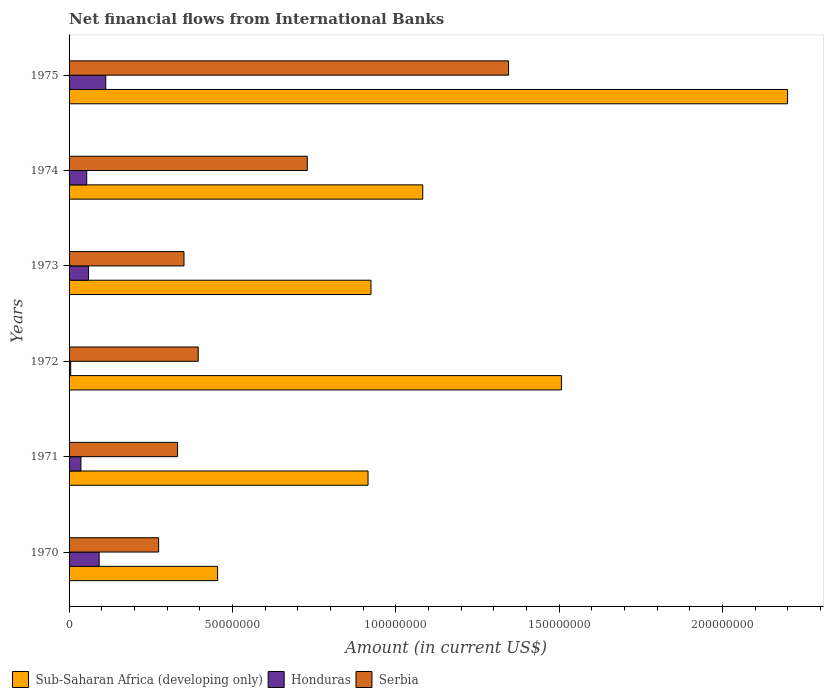Are the number of bars per tick equal to the number of legend labels?
Offer a very short reply. Yes. How many bars are there on the 1st tick from the top?
Provide a succinct answer. 3. In how many cases, is the number of bars for a given year not equal to the number of legend labels?
Provide a succinct answer. 0. What is the net financial aid flows in Honduras in 1970?
Offer a terse response. 9.21e+06. Across all years, what is the maximum net financial aid flows in Honduras?
Your response must be concise. 1.12e+07. Across all years, what is the minimum net financial aid flows in Sub-Saharan Africa (developing only)?
Offer a very short reply. 4.55e+07. In which year was the net financial aid flows in Honduras maximum?
Make the answer very short. 1975. What is the total net financial aid flows in Sub-Saharan Africa (developing only) in the graph?
Your answer should be compact. 7.08e+08. What is the difference between the net financial aid flows in Serbia in 1971 and that in 1972?
Ensure brevity in your answer.  -6.34e+06. What is the difference between the net financial aid flows in Sub-Saharan Africa (developing only) in 1974 and the net financial aid flows in Serbia in 1972?
Offer a very short reply. 6.87e+07. What is the average net financial aid flows in Honduras per year?
Make the answer very short. 5.99e+06. In the year 1971, what is the difference between the net financial aid flows in Honduras and net financial aid flows in Serbia?
Your answer should be compact. -2.96e+07. What is the ratio of the net financial aid flows in Sub-Saharan Africa (developing only) in 1972 to that in 1974?
Your answer should be compact. 1.39. Is the net financial aid flows in Sub-Saharan Africa (developing only) in 1974 less than that in 1975?
Provide a short and direct response. Yes. What is the difference between the highest and the second highest net financial aid flows in Serbia?
Give a very brief answer. 6.16e+07. What is the difference between the highest and the lowest net financial aid flows in Sub-Saharan Africa (developing only)?
Your answer should be compact. 1.74e+08. What does the 1st bar from the top in 1975 represents?
Your answer should be compact. Serbia. What does the 1st bar from the bottom in 1975 represents?
Ensure brevity in your answer.  Sub-Saharan Africa (developing only). Is it the case that in every year, the sum of the net financial aid flows in Sub-Saharan Africa (developing only) and net financial aid flows in Honduras is greater than the net financial aid flows in Serbia?
Your answer should be very brief. Yes. What is the difference between two consecutive major ticks on the X-axis?
Provide a short and direct response. 5.00e+07. Are the values on the major ticks of X-axis written in scientific E-notation?
Make the answer very short. No. Does the graph contain grids?
Provide a short and direct response. No. How many legend labels are there?
Make the answer very short. 3. How are the legend labels stacked?
Your answer should be very brief. Horizontal. What is the title of the graph?
Offer a very short reply. Net financial flows from International Banks. What is the label or title of the X-axis?
Offer a terse response. Amount (in current US$). What is the label or title of the Y-axis?
Your answer should be compact. Years. What is the Amount (in current US$) of Sub-Saharan Africa (developing only) in 1970?
Your response must be concise. 4.55e+07. What is the Amount (in current US$) of Honduras in 1970?
Offer a very short reply. 9.21e+06. What is the Amount (in current US$) of Serbia in 1970?
Offer a terse response. 2.74e+07. What is the Amount (in current US$) in Sub-Saharan Africa (developing only) in 1971?
Your answer should be compact. 9.15e+07. What is the Amount (in current US$) of Honduras in 1971?
Give a very brief answer. 3.63e+06. What is the Amount (in current US$) in Serbia in 1971?
Your answer should be very brief. 3.32e+07. What is the Amount (in current US$) of Sub-Saharan Africa (developing only) in 1972?
Your answer should be very brief. 1.51e+08. What is the Amount (in current US$) of Honduras in 1972?
Provide a succinct answer. 5.02e+05. What is the Amount (in current US$) of Serbia in 1972?
Make the answer very short. 3.95e+07. What is the Amount (in current US$) in Sub-Saharan Africa (developing only) in 1973?
Provide a succinct answer. 9.24e+07. What is the Amount (in current US$) of Honduras in 1973?
Provide a short and direct response. 5.94e+06. What is the Amount (in current US$) in Serbia in 1973?
Ensure brevity in your answer.  3.52e+07. What is the Amount (in current US$) of Sub-Saharan Africa (developing only) in 1974?
Offer a very short reply. 1.08e+08. What is the Amount (in current US$) in Honduras in 1974?
Your answer should be compact. 5.40e+06. What is the Amount (in current US$) of Serbia in 1974?
Give a very brief answer. 7.29e+07. What is the Amount (in current US$) of Sub-Saharan Africa (developing only) in 1975?
Your answer should be compact. 2.20e+08. What is the Amount (in current US$) of Honduras in 1975?
Ensure brevity in your answer.  1.12e+07. What is the Amount (in current US$) of Serbia in 1975?
Offer a terse response. 1.35e+08. Across all years, what is the maximum Amount (in current US$) in Sub-Saharan Africa (developing only)?
Your answer should be compact. 2.20e+08. Across all years, what is the maximum Amount (in current US$) of Honduras?
Provide a succinct answer. 1.12e+07. Across all years, what is the maximum Amount (in current US$) of Serbia?
Your answer should be compact. 1.35e+08. Across all years, what is the minimum Amount (in current US$) in Sub-Saharan Africa (developing only)?
Keep it short and to the point. 4.55e+07. Across all years, what is the minimum Amount (in current US$) of Honduras?
Your response must be concise. 5.02e+05. Across all years, what is the minimum Amount (in current US$) in Serbia?
Make the answer very short. 2.74e+07. What is the total Amount (in current US$) of Sub-Saharan Africa (developing only) in the graph?
Make the answer very short. 7.08e+08. What is the total Amount (in current US$) of Honduras in the graph?
Offer a terse response. 3.59e+07. What is the total Amount (in current US$) in Serbia in the graph?
Make the answer very short. 3.43e+08. What is the difference between the Amount (in current US$) in Sub-Saharan Africa (developing only) in 1970 and that in 1971?
Provide a succinct answer. -4.61e+07. What is the difference between the Amount (in current US$) in Honduras in 1970 and that in 1971?
Your answer should be compact. 5.58e+06. What is the difference between the Amount (in current US$) in Serbia in 1970 and that in 1971?
Your response must be concise. -5.78e+06. What is the difference between the Amount (in current US$) of Sub-Saharan Africa (developing only) in 1970 and that in 1972?
Keep it short and to the point. -1.05e+08. What is the difference between the Amount (in current US$) in Honduras in 1970 and that in 1972?
Your answer should be compact. 8.71e+06. What is the difference between the Amount (in current US$) in Serbia in 1970 and that in 1972?
Make the answer very short. -1.21e+07. What is the difference between the Amount (in current US$) of Sub-Saharan Africa (developing only) in 1970 and that in 1973?
Your answer should be compact. -4.70e+07. What is the difference between the Amount (in current US$) in Honduras in 1970 and that in 1973?
Your answer should be very brief. 3.27e+06. What is the difference between the Amount (in current US$) in Serbia in 1970 and that in 1973?
Ensure brevity in your answer.  -7.76e+06. What is the difference between the Amount (in current US$) of Sub-Saharan Africa (developing only) in 1970 and that in 1974?
Your answer should be compact. -6.28e+07. What is the difference between the Amount (in current US$) of Honduras in 1970 and that in 1974?
Your answer should be compact. 3.81e+06. What is the difference between the Amount (in current US$) in Serbia in 1970 and that in 1974?
Your answer should be compact. -4.55e+07. What is the difference between the Amount (in current US$) in Sub-Saharan Africa (developing only) in 1970 and that in 1975?
Give a very brief answer. -1.74e+08. What is the difference between the Amount (in current US$) in Honduras in 1970 and that in 1975?
Ensure brevity in your answer.  -2.03e+06. What is the difference between the Amount (in current US$) of Serbia in 1970 and that in 1975?
Provide a succinct answer. -1.07e+08. What is the difference between the Amount (in current US$) in Sub-Saharan Africa (developing only) in 1971 and that in 1972?
Provide a succinct answer. -5.92e+07. What is the difference between the Amount (in current US$) of Honduras in 1971 and that in 1972?
Make the answer very short. 3.13e+06. What is the difference between the Amount (in current US$) of Serbia in 1971 and that in 1972?
Offer a terse response. -6.34e+06. What is the difference between the Amount (in current US$) of Sub-Saharan Africa (developing only) in 1971 and that in 1973?
Your answer should be very brief. -9.02e+05. What is the difference between the Amount (in current US$) in Honduras in 1971 and that in 1973?
Keep it short and to the point. -2.30e+06. What is the difference between the Amount (in current US$) of Serbia in 1971 and that in 1973?
Provide a short and direct response. -1.98e+06. What is the difference between the Amount (in current US$) of Sub-Saharan Africa (developing only) in 1971 and that in 1974?
Offer a very short reply. -1.68e+07. What is the difference between the Amount (in current US$) in Honduras in 1971 and that in 1974?
Your answer should be compact. -1.77e+06. What is the difference between the Amount (in current US$) of Serbia in 1971 and that in 1974?
Offer a very short reply. -3.97e+07. What is the difference between the Amount (in current US$) of Sub-Saharan Africa (developing only) in 1971 and that in 1975?
Give a very brief answer. -1.28e+08. What is the difference between the Amount (in current US$) of Honduras in 1971 and that in 1975?
Your answer should be compact. -7.60e+06. What is the difference between the Amount (in current US$) in Serbia in 1971 and that in 1975?
Give a very brief answer. -1.01e+08. What is the difference between the Amount (in current US$) of Sub-Saharan Africa (developing only) in 1972 and that in 1973?
Your response must be concise. 5.83e+07. What is the difference between the Amount (in current US$) of Honduras in 1972 and that in 1973?
Offer a very short reply. -5.43e+06. What is the difference between the Amount (in current US$) in Serbia in 1972 and that in 1973?
Your answer should be very brief. 4.36e+06. What is the difference between the Amount (in current US$) of Sub-Saharan Africa (developing only) in 1972 and that in 1974?
Keep it short and to the point. 4.24e+07. What is the difference between the Amount (in current US$) of Honduras in 1972 and that in 1974?
Offer a very short reply. -4.90e+06. What is the difference between the Amount (in current US$) in Serbia in 1972 and that in 1974?
Provide a succinct answer. -3.34e+07. What is the difference between the Amount (in current US$) of Sub-Saharan Africa (developing only) in 1972 and that in 1975?
Keep it short and to the point. -6.92e+07. What is the difference between the Amount (in current US$) in Honduras in 1972 and that in 1975?
Keep it short and to the point. -1.07e+07. What is the difference between the Amount (in current US$) in Serbia in 1972 and that in 1975?
Your answer should be very brief. -9.50e+07. What is the difference between the Amount (in current US$) in Sub-Saharan Africa (developing only) in 1973 and that in 1974?
Your answer should be very brief. -1.58e+07. What is the difference between the Amount (in current US$) in Honduras in 1973 and that in 1974?
Your answer should be very brief. 5.33e+05. What is the difference between the Amount (in current US$) of Serbia in 1973 and that in 1974?
Offer a very short reply. -3.77e+07. What is the difference between the Amount (in current US$) in Sub-Saharan Africa (developing only) in 1973 and that in 1975?
Keep it short and to the point. -1.28e+08. What is the difference between the Amount (in current US$) in Honduras in 1973 and that in 1975?
Provide a short and direct response. -5.30e+06. What is the difference between the Amount (in current US$) in Serbia in 1973 and that in 1975?
Make the answer very short. -9.94e+07. What is the difference between the Amount (in current US$) of Sub-Saharan Africa (developing only) in 1974 and that in 1975?
Your response must be concise. -1.12e+08. What is the difference between the Amount (in current US$) of Honduras in 1974 and that in 1975?
Offer a very short reply. -5.83e+06. What is the difference between the Amount (in current US$) of Serbia in 1974 and that in 1975?
Your answer should be very brief. -6.16e+07. What is the difference between the Amount (in current US$) in Sub-Saharan Africa (developing only) in 1970 and the Amount (in current US$) in Honduras in 1971?
Keep it short and to the point. 4.18e+07. What is the difference between the Amount (in current US$) of Sub-Saharan Africa (developing only) in 1970 and the Amount (in current US$) of Serbia in 1971?
Keep it short and to the point. 1.23e+07. What is the difference between the Amount (in current US$) in Honduras in 1970 and the Amount (in current US$) in Serbia in 1971?
Provide a short and direct response. -2.40e+07. What is the difference between the Amount (in current US$) of Sub-Saharan Africa (developing only) in 1970 and the Amount (in current US$) of Honduras in 1972?
Your answer should be compact. 4.50e+07. What is the difference between the Amount (in current US$) in Sub-Saharan Africa (developing only) in 1970 and the Amount (in current US$) in Serbia in 1972?
Your answer should be compact. 5.93e+06. What is the difference between the Amount (in current US$) in Honduras in 1970 and the Amount (in current US$) in Serbia in 1972?
Provide a short and direct response. -3.03e+07. What is the difference between the Amount (in current US$) in Sub-Saharan Africa (developing only) in 1970 and the Amount (in current US$) in Honduras in 1973?
Provide a short and direct response. 3.95e+07. What is the difference between the Amount (in current US$) of Sub-Saharan Africa (developing only) in 1970 and the Amount (in current US$) of Serbia in 1973?
Your answer should be compact. 1.03e+07. What is the difference between the Amount (in current US$) in Honduras in 1970 and the Amount (in current US$) in Serbia in 1973?
Offer a terse response. -2.60e+07. What is the difference between the Amount (in current US$) of Sub-Saharan Africa (developing only) in 1970 and the Amount (in current US$) of Honduras in 1974?
Keep it short and to the point. 4.01e+07. What is the difference between the Amount (in current US$) of Sub-Saharan Africa (developing only) in 1970 and the Amount (in current US$) of Serbia in 1974?
Keep it short and to the point. -2.75e+07. What is the difference between the Amount (in current US$) in Honduras in 1970 and the Amount (in current US$) in Serbia in 1974?
Offer a very short reply. -6.37e+07. What is the difference between the Amount (in current US$) of Sub-Saharan Africa (developing only) in 1970 and the Amount (in current US$) of Honduras in 1975?
Your answer should be compact. 3.42e+07. What is the difference between the Amount (in current US$) of Sub-Saharan Africa (developing only) in 1970 and the Amount (in current US$) of Serbia in 1975?
Your answer should be very brief. -8.91e+07. What is the difference between the Amount (in current US$) of Honduras in 1970 and the Amount (in current US$) of Serbia in 1975?
Offer a terse response. -1.25e+08. What is the difference between the Amount (in current US$) in Sub-Saharan Africa (developing only) in 1971 and the Amount (in current US$) in Honduras in 1972?
Provide a short and direct response. 9.10e+07. What is the difference between the Amount (in current US$) of Sub-Saharan Africa (developing only) in 1971 and the Amount (in current US$) of Serbia in 1972?
Provide a short and direct response. 5.20e+07. What is the difference between the Amount (in current US$) of Honduras in 1971 and the Amount (in current US$) of Serbia in 1972?
Keep it short and to the point. -3.59e+07. What is the difference between the Amount (in current US$) of Sub-Saharan Africa (developing only) in 1971 and the Amount (in current US$) of Honduras in 1973?
Your answer should be compact. 8.56e+07. What is the difference between the Amount (in current US$) of Sub-Saharan Africa (developing only) in 1971 and the Amount (in current US$) of Serbia in 1973?
Your response must be concise. 5.63e+07. What is the difference between the Amount (in current US$) in Honduras in 1971 and the Amount (in current US$) in Serbia in 1973?
Ensure brevity in your answer.  -3.15e+07. What is the difference between the Amount (in current US$) of Sub-Saharan Africa (developing only) in 1971 and the Amount (in current US$) of Honduras in 1974?
Your response must be concise. 8.61e+07. What is the difference between the Amount (in current US$) of Sub-Saharan Africa (developing only) in 1971 and the Amount (in current US$) of Serbia in 1974?
Offer a very short reply. 1.86e+07. What is the difference between the Amount (in current US$) of Honduras in 1971 and the Amount (in current US$) of Serbia in 1974?
Provide a short and direct response. -6.93e+07. What is the difference between the Amount (in current US$) in Sub-Saharan Africa (developing only) in 1971 and the Amount (in current US$) in Honduras in 1975?
Provide a succinct answer. 8.03e+07. What is the difference between the Amount (in current US$) in Sub-Saharan Africa (developing only) in 1971 and the Amount (in current US$) in Serbia in 1975?
Your answer should be very brief. -4.30e+07. What is the difference between the Amount (in current US$) of Honduras in 1971 and the Amount (in current US$) of Serbia in 1975?
Give a very brief answer. -1.31e+08. What is the difference between the Amount (in current US$) of Sub-Saharan Africa (developing only) in 1972 and the Amount (in current US$) of Honduras in 1973?
Make the answer very short. 1.45e+08. What is the difference between the Amount (in current US$) of Sub-Saharan Africa (developing only) in 1972 and the Amount (in current US$) of Serbia in 1973?
Your answer should be very brief. 1.16e+08. What is the difference between the Amount (in current US$) in Honduras in 1972 and the Amount (in current US$) in Serbia in 1973?
Keep it short and to the point. -3.47e+07. What is the difference between the Amount (in current US$) in Sub-Saharan Africa (developing only) in 1972 and the Amount (in current US$) in Honduras in 1974?
Your response must be concise. 1.45e+08. What is the difference between the Amount (in current US$) in Sub-Saharan Africa (developing only) in 1972 and the Amount (in current US$) in Serbia in 1974?
Provide a succinct answer. 7.78e+07. What is the difference between the Amount (in current US$) in Honduras in 1972 and the Amount (in current US$) in Serbia in 1974?
Offer a very short reply. -7.24e+07. What is the difference between the Amount (in current US$) of Sub-Saharan Africa (developing only) in 1972 and the Amount (in current US$) of Honduras in 1975?
Offer a very short reply. 1.39e+08. What is the difference between the Amount (in current US$) in Sub-Saharan Africa (developing only) in 1972 and the Amount (in current US$) in Serbia in 1975?
Your answer should be very brief. 1.62e+07. What is the difference between the Amount (in current US$) of Honduras in 1972 and the Amount (in current US$) of Serbia in 1975?
Make the answer very short. -1.34e+08. What is the difference between the Amount (in current US$) in Sub-Saharan Africa (developing only) in 1973 and the Amount (in current US$) in Honduras in 1974?
Keep it short and to the point. 8.70e+07. What is the difference between the Amount (in current US$) in Sub-Saharan Africa (developing only) in 1973 and the Amount (in current US$) in Serbia in 1974?
Make the answer very short. 1.95e+07. What is the difference between the Amount (in current US$) in Honduras in 1973 and the Amount (in current US$) in Serbia in 1974?
Give a very brief answer. -6.70e+07. What is the difference between the Amount (in current US$) of Sub-Saharan Africa (developing only) in 1973 and the Amount (in current US$) of Honduras in 1975?
Your response must be concise. 8.12e+07. What is the difference between the Amount (in current US$) of Sub-Saharan Africa (developing only) in 1973 and the Amount (in current US$) of Serbia in 1975?
Your response must be concise. -4.21e+07. What is the difference between the Amount (in current US$) of Honduras in 1973 and the Amount (in current US$) of Serbia in 1975?
Your answer should be very brief. -1.29e+08. What is the difference between the Amount (in current US$) of Sub-Saharan Africa (developing only) in 1974 and the Amount (in current US$) of Honduras in 1975?
Your answer should be compact. 9.70e+07. What is the difference between the Amount (in current US$) of Sub-Saharan Africa (developing only) in 1974 and the Amount (in current US$) of Serbia in 1975?
Ensure brevity in your answer.  -2.63e+07. What is the difference between the Amount (in current US$) of Honduras in 1974 and the Amount (in current US$) of Serbia in 1975?
Give a very brief answer. -1.29e+08. What is the average Amount (in current US$) in Sub-Saharan Africa (developing only) per year?
Your response must be concise. 1.18e+08. What is the average Amount (in current US$) of Honduras per year?
Make the answer very short. 5.99e+06. What is the average Amount (in current US$) of Serbia per year?
Your answer should be compact. 5.71e+07. In the year 1970, what is the difference between the Amount (in current US$) of Sub-Saharan Africa (developing only) and Amount (in current US$) of Honduras?
Offer a terse response. 3.63e+07. In the year 1970, what is the difference between the Amount (in current US$) of Sub-Saharan Africa (developing only) and Amount (in current US$) of Serbia?
Keep it short and to the point. 1.80e+07. In the year 1970, what is the difference between the Amount (in current US$) in Honduras and Amount (in current US$) in Serbia?
Your response must be concise. -1.82e+07. In the year 1971, what is the difference between the Amount (in current US$) in Sub-Saharan Africa (developing only) and Amount (in current US$) in Honduras?
Offer a terse response. 8.79e+07. In the year 1971, what is the difference between the Amount (in current US$) of Sub-Saharan Africa (developing only) and Amount (in current US$) of Serbia?
Make the answer very short. 5.83e+07. In the year 1971, what is the difference between the Amount (in current US$) of Honduras and Amount (in current US$) of Serbia?
Provide a succinct answer. -2.96e+07. In the year 1972, what is the difference between the Amount (in current US$) in Sub-Saharan Africa (developing only) and Amount (in current US$) in Honduras?
Provide a short and direct response. 1.50e+08. In the year 1972, what is the difference between the Amount (in current US$) of Sub-Saharan Africa (developing only) and Amount (in current US$) of Serbia?
Provide a succinct answer. 1.11e+08. In the year 1972, what is the difference between the Amount (in current US$) in Honduras and Amount (in current US$) in Serbia?
Give a very brief answer. -3.90e+07. In the year 1973, what is the difference between the Amount (in current US$) of Sub-Saharan Africa (developing only) and Amount (in current US$) of Honduras?
Your answer should be compact. 8.65e+07. In the year 1973, what is the difference between the Amount (in current US$) of Sub-Saharan Africa (developing only) and Amount (in current US$) of Serbia?
Keep it short and to the point. 5.72e+07. In the year 1973, what is the difference between the Amount (in current US$) of Honduras and Amount (in current US$) of Serbia?
Ensure brevity in your answer.  -2.92e+07. In the year 1974, what is the difference between the Amount (in current US$) in Sub-Saharan Africa (developing only) and Amount (in current US$) in Honduras?
Ensure brevity in your answer.  1.03e+08. In the year 1974, what is the difference between the Amount (in current US$) in Sub-Saharan Africa (developing only) and Amount (in current US$) in Serbia?
Your answer should be very brief. 3.53e+07. In the year 1974, what is the difference between the Amount (in current US$) of Honduras and Amount (in current US$) of Serbia?
Make the answer very short. -6.75e+07. In the year 1975, what is the difference between the Amount (in current US$) of Sub-Saharan Africa (developing only) and Amount (in current US$) of Honduras?
Ensure brevity in your answer.  2.09e+08. In the year 1975, what is the difference between the Amount (in current US$) of Sub-Saharan Africa (developing only) and Amount (in current US$) of Serbia?
Ensure brevity in your answer.  8.54e+07. In the year 1975, what is the difference between the Amount (in current US$) of Honduras and Amount (in current US$) of Serbia?
Make the answer very short. -1.23e+08. What is the ratio of the Amount (in current US$) in Sub-Saharan Africa (developing only) in 1970 to that in 1971?
Keep it short and to the point. 0.5. What is the ratio of the Amount (in current US$) in Honduras in 1970 to that in 1971?
Provide a succinct answer. 2.54. What is the ratio of the Amount (in current US$) of Serbia in 1970 to that in 1971?
Keep it short and to the point. 0.83. What is the ratio of the Amount (in current US$) in Sub-Saharan Africa (developing only) in 1970 to that in 1972?
Provide a short and direct response. 0.3. What is the ratio of the Amount (in current US$) of Honduras in 1970 to that in 1972?
Ensure brevity in your answer.  18.34. What is the ratio of the Amount (in current US$) in Serbia in 1970 to that in 1972?
Offer a terse response. 0.69. What is the ratio of the Amount (in current US$) of Sub-Saharan Africa (developing only) in 1970 to that in 1973?
Your answer should be compact. 0.49. What is the ratio of the Amount (in current US$) in Honduras in 1970 to that in 1973?
Your response must be concise. 1.55. What is the ratio of the Amount (in current US$) in Serbia in 1970 to that in 1973?
Keep it short and to the point. 0.78. What is the ratio of the Amount (in current US$) in Sub-Saharan Africa (developing only) in 1970 to that in 1974?
Your answer should be very brief. 0.42. What is the ratio of the Amount (in current US$) in Honduras in 1970 to that in 1974?
Give a very brief answer. 1.7. What is the ratio of the Amount (in current US$) of Serbia in 1970 to that in 1974?
Provide a succinct answer. 0.38. What is the ratio of the Amount (in current US$) in Sub-Saharan Africa (developing only) in 1970 to that in 1975?
Provide a short and direct response. 0.21. What is the ratio of the Amount (in current US$) of Honduras in 1970 to that in 1975?
Ensure brevity in your answer.  0.82. What is the ratio of the Amount (in current US$) in Serbia in 1970 to that in 1975?
Provide a succinct answer. 0.2. What is the ratio of the Amount (in current US$) in Sub-Saharan Africa (developing only) in 1971 to that in 1972?
Offer a very short reply. 0.61. What is the ratio of the Amount (in current US$) of Honduras in 1971 to that in 1972?
Provide a short and direct response. 7.24. What is the ratio of the Amount (in current US$) of Serbia in 1971 to that in 1972?
Ensure brevity in your answer.  0.84. What is the ratio of the Amount (in current US$) of Sub-Saharan Africa (developing only) in 1971 to that in 1973?
Give a very brief answer. 0.99. What is the ratio of the Amount (in current US$) in Honduras in 1971 to that in 1973?
Your answer should be very brief. 0.61. What is the ratio of the Amount (in current US$) in Serbia in 1971 to that in 1973?
Give a very brief answer. 0.94. What is the ratio of the Amount (in current US$) in Sub-Saharan Africa (developing only) in 1971 to that in 1974?
Make the answer very short. 0.85. What is the ratio of the Amount (in current US$) of Honduras in 1971 to that in 1974?
Ensure brevity in your answer.  0.67. What is the ratio of the Amount (in current US$) of Serbia in 1971 to that in 1974?
Your response must be concise. 0.46. What is the ratio of the Amount (in current US$) of Sub-Saharan Africa (developing only) in 1971 to that in 1975?
Provide a short and direct response. 0.42. What is the ratio of the Amount (in current US$) of Honduras in 1971 to that in 1975?
Offer a terse response. 0.32. What is the ratio of the Amount (in current US$) of Serbia in 1971 to that in 1975?
Your answer should be compact. 0.25. What is the ratio of the Amount (in current US$) in Sub-Saharan Africa (developing only) in 1972 to that in 1973?
Offer a terse response. 1.63. What is the ratio of the Amount (in current US$) of Honduras in 1972 to that in 1973?
Ensure brevity in your answer.  0.08. What is the ratio of the Amount (in current US$) of Serbia in 1972 to that in 1973?
Your answer should be very brief. 1.12. What is the ratio of the Amount (in current US$) in Sub-Saharan Africa (developing only) in 1972 to that in 1974?
Offer a very short reply. 1.39. What is the ratio of the Amount (in current US$) in Honduras in 1972 to that in 1974?
Offer a very short reply. 0.09. What is the ratio of the Amount (in current US$) in Serbia in 1972 to that in 1974?
Your response must be concise. 0.54. What is the ratio of the Amount (in current US$) in Sub-Saharan Africa (developing only) in 1972 to that in 1975?
Give a very brief answer. 0.69. What is the ratio of the Amount (in current US$) of Honduras in 1972 to that in 1975?
Offer a very short reply. 0.04. What is the ratio of the Amount (in current US$) in Serbia in 1972 to that in 1975?
Provide a short and direct response. 0.29. What is the ratio of the Amount (in current US$) of Sub-Saharan Africa (developing only) in 1973 to that in 1974?
Your response must be concise. 0.85. What is the ratio of the Amount (in current US$) of Honduras in 1973 to that in 1974?
Make the answer very short. 1.1. What is the ratio of the Amount (in current US$) of Serbia in 1973 to that in 1974?
Keep it short and to the point. 0.48. What is the ratio of the Amount (in current US$) in Sub-Saharan Africa (developing only) in 1973 to that in 1975?
Keep it short and to the point. 0.42. What is the ratio of the Amount (in current US$) of Honduras in 1973 to that in 1975?
Provide a succinct answer. 0.53. What is the ratio of the Amount (in current US$) in Serbia in 1973 to that in 1975?
Your answer should be very brief. 0.26. What is the ratio of the Amount (in current US$) in Sub-Saharan Africa (developing only) in 1974 to that in 1975?
Keep it short and to the point. 0.49. What is the ratio of the Amount (in current US$) in Honduras in 1974 to that in 1975?
Offer a terse response. 0.48. What is the ratio of the Amount (in current US$) in Serbia in 1974 to that in 1975?
Provide a short and direct response. 0.54. What is the difference between the highest and the second highest Amount (in current US$) in Sub-Saharan Africa (developing only)?
Offer a very short reply. 6.92e+07. What is the difference between the highest and the second highest Amount (in current US$) of Honduras?
Provide a succinct answer. 2.03e+06. What is the difference between the highest and the second highest Amount (in current US$) of Serbia?
Give a very brief answer. 6.16e+07. What is the difference between the highest and the lowest Amount (in current US$) of Sub-Saharan Africa (developing only)?
Your response must be concise. 1.74e+08. What is the difference between the highest and the lowest Amount (in current US$) of Honduras?
Give a very brief answer. 1.07e+07. What is the difference between the highest and the lowest Amount (in current US$) in Serbia?
Your answer should be compact. 1.07e+08. 